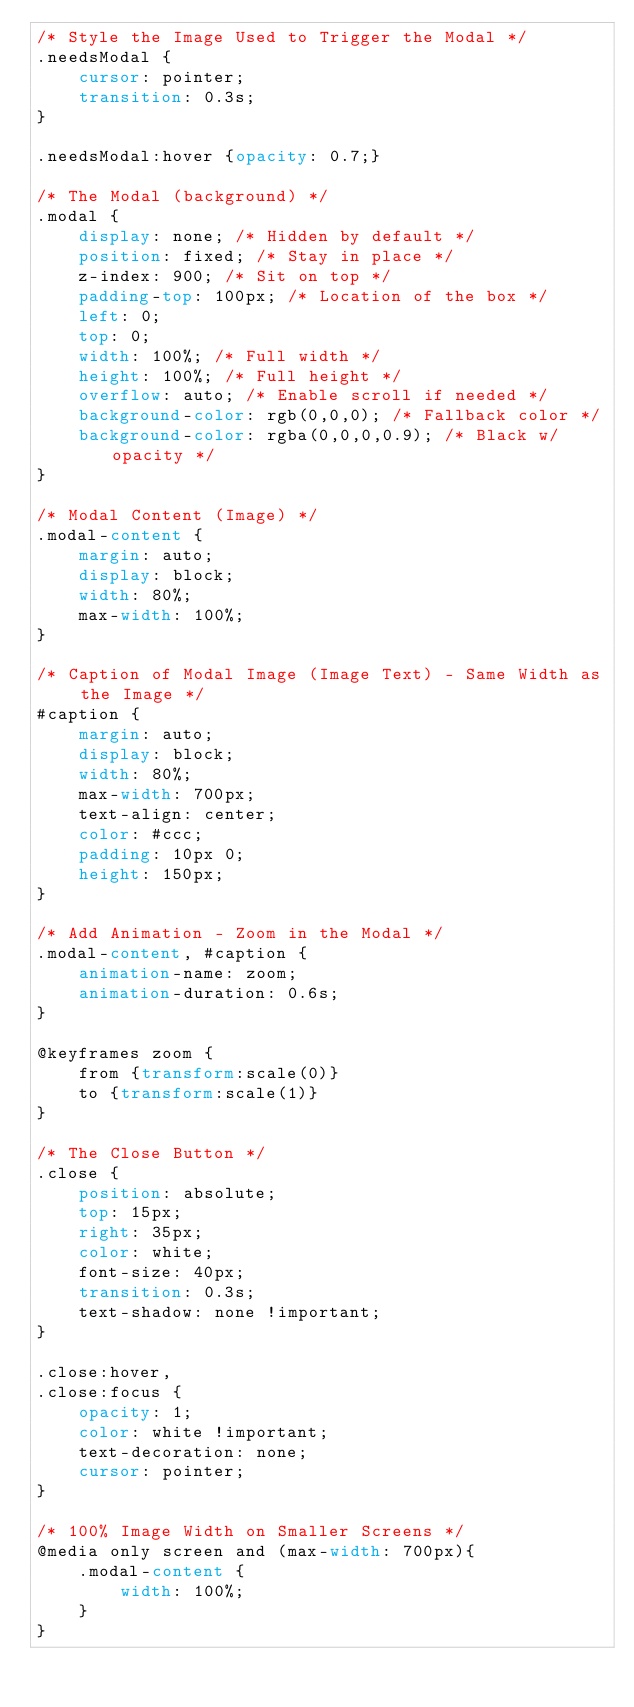<code> <loc_0><loc_0><loc_500><loc_500><_CSS_>/* Style the Image Used to Trigger the Modal */
.needsModal {
    cursor: pointer;
    transition: 0.3s;
}

.needsModal:hover {opacity: 0.7;}

/* The Modal (background) */
.modal {
    display: none; /* Hidden by default */
    position: fixed; /* Stay in place */
    z-index: 900; /* Sit on top */
    padding-top: 100px; /* Location of the box */
    left: 0;
    top: 0;
    width: 100%; /* Full width */
    height: 100%; /* Full height */
    overflow: auto; /* Enable scroll if needed */
    background-color: rgb(0,0,0); /* Fallback color */
    background-color: rgba(0,0,0,0.9); /* Black w/ opacity */
}

/* Modal Content (Image) */
.modal-content {
    margin: auto;
    display: block;
    width: 80%;
    max-width: 100%;
}

/* Caption of Modal Image (Image Text) - Same Width as the Image */
#caption {
    margin: auto;
    display: block;
    width: 80%;
    max-width: 700px;
    text-align: center;
    color: #ccc;
    padding: 10px 0;
    height: 150px;
}

/* Add Animation - Zoom in the Modal */
.modal-content, #caption { 
    animation-name: zoom;
    animation-duration: 0.6s;
}

@keyframes zoom {
    from {transform:scale(0)} 
    to {transform:scale(1)}
}

/* The Close Button */
.close {
    position: absolute;
    top: 15px;
    right: 35px;
    color: white;
    font-size: 40px;
    transition: 0.3s;
    text-shadow: none !important;
}

.close:hover,
.close:focus {
    opacity: 1;
    color: white !important;
    text-decoration: none;
    cursor: pointer;
}

/* 100% Image Width on Smaller Screens */
@media only screen and (max-width: 700px){
    .modal-content {
        width: 100%;
    }
}
</code> 